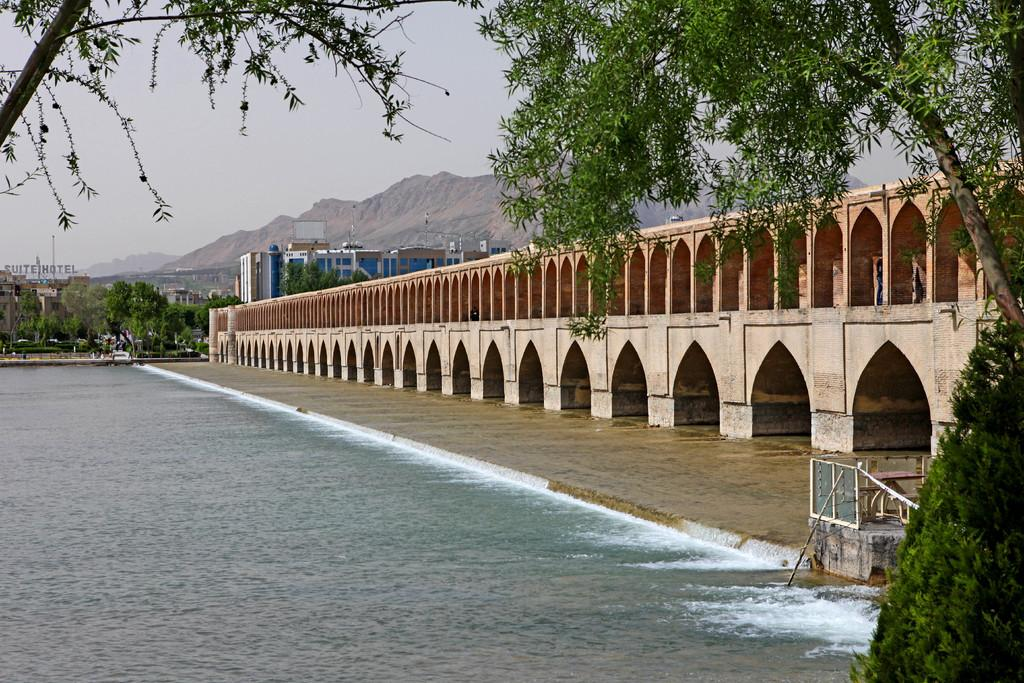What type of natural feature is present in the image? There is a river in the image. What structure can be seen crossing the river? There is a bridge in the image. What type of vegetation is visible in the image? There are trees and plants in the image. What type of man-made structures can be seen in the image? There are buildings and houses in the image. How much time does it take for the trees to grow in the image? The image does not provide information about the growth rate of the trees, so it is impossible to determine how much time it takes for them to grow. 